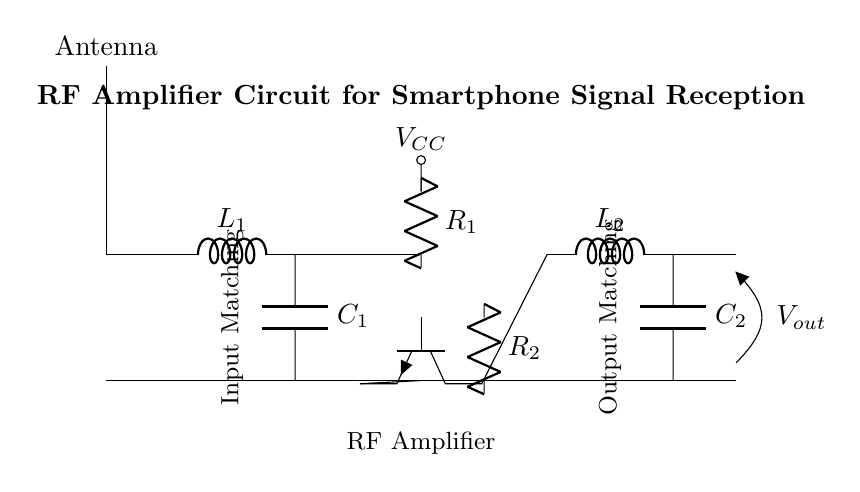What is the input component of this circuit? The input component is an antenna, which is indicated at the top left of the diagram. It is the first component where the RF signal is captured.
Answer: antenna Which component provides biasing in the circuit? The biasing is provided by the resistor labeled R1, which connects to the VCC supply and also to the RF amplifier section. This ensures that the amplifier operates in the correct range.
Answer: R1 How many capacitors are present in the circuit? There are two capacitors in the circuit, labeled C1 and C2, which are part of the matching networks for both input and output.
Answer: 2 What is the output voltage labeled as? The output voltage is labeled as Vout, which is located at the output terminal on the right side of the circuit diagram. This is the voltage after the RF amplifier processes the signal.
Answer: Vout What is the function of the matching network in the circuit? The matching network, made up of components L1 and C1 at the input and L2 and C2 at the output, ensures impedance matching to maximize power transfer and improve signal quality.
Answer: impedance matching Which component directly amplifies the RF signal? The RF signal is directly amplified by the transistor labeled Q1, which is placed centrally within the amplifier section. This component is crucial for signal enhancement.
Answer: Q1 What are the names of the inductors used in this circuit? The names of the inductors in this circuit are L1 and L2. L1 is used in the input matching network, and L2 is used in the output matching network.
Answer: L1, L2 